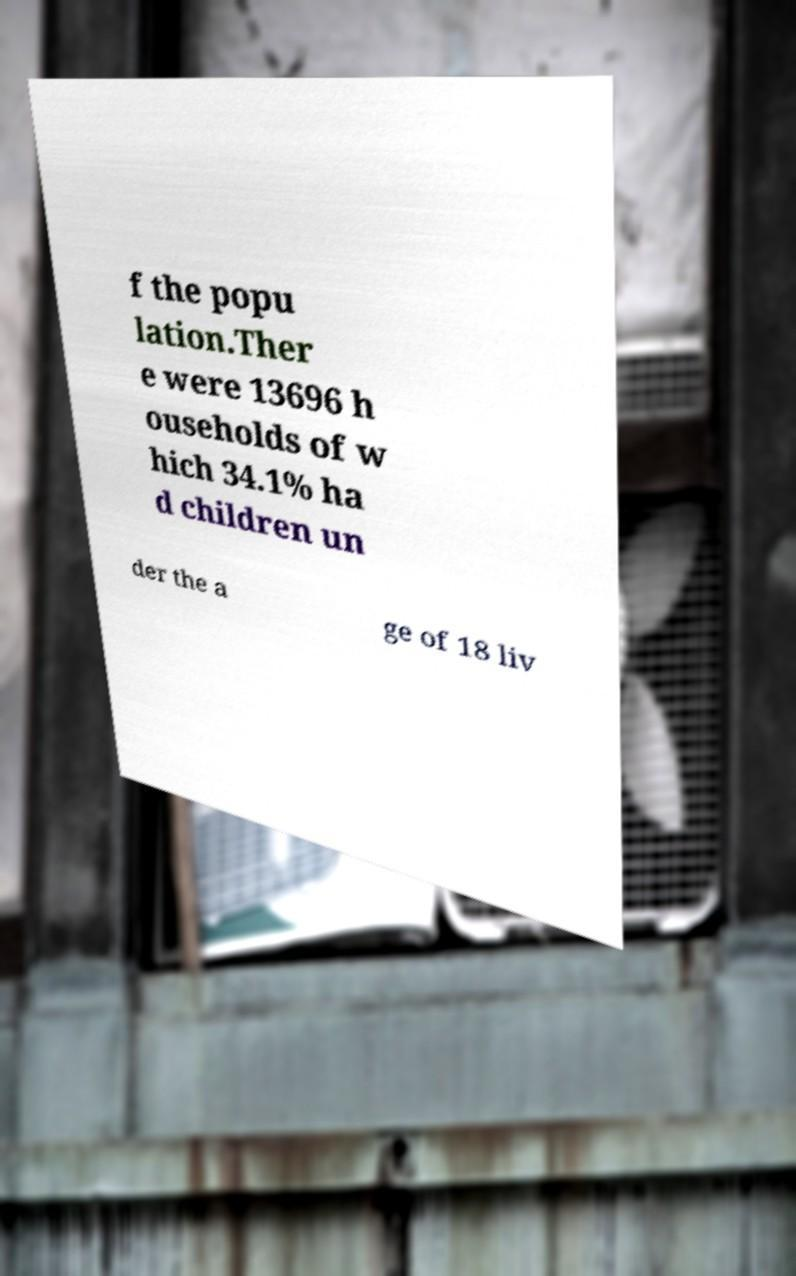Can you read and provide the text displayed in the image?This photo seems to have some interesting text. Can you extract and type it out for me? f the popu lation.Ther e were 13696 h ouseholds of w hich 34.1% ha d children un der the a ge of 18 liv 